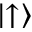<formula> <loc_0><loc_0><loc_500><loc_500>\left | \uparrow \right \rangle</formula> 